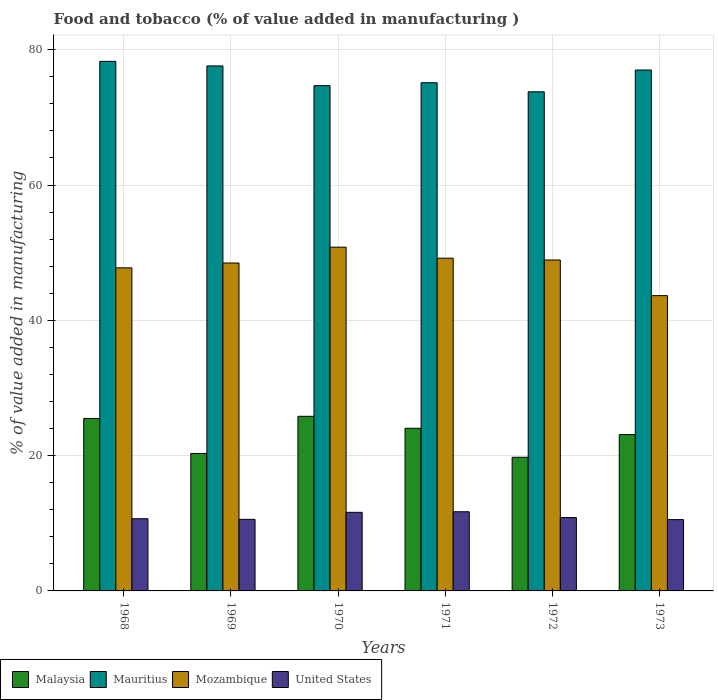Are the number of bars per tick equal to the number of legend labels?
Ensure brevity in your answer.  Yes. Are the number of bars on each tick of the X-axis equal?
Give a very brief answer. Yes. What is the value added in manufacturing food and tobacco in Malaysia in 1973?
Make the answer very short. 23.12. Across all years, what is the maximum value added in manufacturing food and tobacco in Mozambique?
Keep it short and to the point. 50.82. Across all years, what is the minimum value added in manufacturing food and tobacco in United States?
Your answer should be very brief. 10.54. What is the total value added in manufacturing food and tobacco in Mozambique in the graph?
Keep it short and to the point. 288.81. What is the difference between the value added in manufacturing food and tobacco in United States in 1969 and that in 1972?
Give a very brief answer. -0.27. What is the difference between the value added in manufacturing food and tobacco in Mauritius in 1968 and the value added in manufacturing food and tobacco in Malaysia in 1973?
Your answer should be compact. 55.17. What is the average value added in manufacturing food and tobacco in Mauritius per year?
Your answer should be very brief. 76.08. In the year 1972, what is the difference between the value added in manufacturing food and tobacco in United States and value added in manufacturing food and tobacco in Mauritius?
Offer a very short reply. -62.94. What is the ratio of the value added in manufacturing food and tobacco in United States in 1970 to that in 1973?
Provide a succinct answer. 1.1. What is the difference between the highest and the second highest value added in manufacturing food and tobacco in Malaysia?
Make the answer very short. 0.32. What is the difference between the highest and the lowest value added in manufacturing food and tobacco in United States?
Offer a terse response. 1.16. In how many years, is the value added in manufacturing food and tobacco in Malaysia greater than the average value added in manufacturing food and tobacco in Malaysia taken over all years?
Offer a very short reply. 4. Is the sum of the value added in manufacturing food and tobacco in United States in 1970 and 1971 greater than the maximum value added in manufacturing food and tobacco in Mauritius across all years?
Make the answer very short. No. What does the 1st bar from the left in 1971 represents?
Offer a terse response. Malaysia. What does the 4th bar from the right in 1970 represents?
Offer a terse response. Malaysia. Is it the case that in every year, the sum of the value added in manufacturing food and tobacco in Mozambique and value added in manufacturing food and tobacco in Malaysia is greater than the value added in manufacturing food and tobacco in Mauritius?
Ensure brevity in your answer.  No. How many bars are there?
Provide a succinct answer. 24. How many years are there in the graph?
Give a very brief answer. 6. Are the values on the major ticks of Y-axis written in scientific E-notation?
Ensure brevity in your answer.  No. Does the graph contain any zero values?
Give a very brief answer. No. Does the graph contain grids?
Give a very brief answer. Yes. Where does the legend appear in the graph?
Give a very brief answer. Bottom left. What is the title of the graph?
Keep it short and to the point. Food and tobacco (% of value added in manufacturing ). Does "South Sudan" appear as one of the legend labels in the graph?
Provide a succinct answer. No. What is the label or title of the X-axis?
Your answer should be very brief. Years. What is the label or title of the Y-axis?
Your answer should be compact. % of value added in manufacturing. What is the % of value added in manufacturing of Malaysia in 1968?
Offer a very short reply. 25.49. What is the % of value added in manufacturing in Mauritius in 1968?
Ensure brevity in your answer.  78.28. What is the % of value added in manufacturing in Mozambique in 1968?
Your response must be concise. 47.76. What is the % of value added in manufacturing of United States in 1968?
Give a very brief answer. 10.67. What is the % of value added in manufacturing of Malaysia in 1969?
Ensure brevity in your answer.  20.32. What is the % of value added in manufacturing in Mauritius in 1969?
Your response must be concise. 77.61. What is the % of value added in manufacturing of Mozambique in 1969?
Offer a terse response. 48.47. What is the % of value added in manufacturing in United States in 1969?
Give a very brief answer. 10.58. What is the % of value added in manufacturing of Malaysia in 1970?
Provide a succinct answer. 25.81. What is the % of value added in manufacturing of Mauritius in 1970?
Provide a succinct answer. 74.69. What is the % of value added in manufacturing of Mozambique in 1970?
Make the answer very short. 50.82. What is the % of value added in manufacturing of United States in 1970?
Keep it short and to the point. 11.62. What is the % of value added in manufacturing in Malaysia in 1971?
Ensure brevity in your answer.  24.04. What is the % of value added in manufacturing in Mauritius in 1971?
Provide a succinct answer. 75.13. What is the % of value added in manufacturing of Mozambique in 1971?
Your answer should be compact. 49.19. What is the % of value added in manufacturing in United States in 1971?
Keep it short and to the point. 11.71. What is the % of value added in manufacturing in Malaysia in 1972?
Your response must be concise. 19.76. What is the % of value added in manufacturing in Mauritius in 1972?
Make the answer very short. 73.79. What is the % of value added in manufacturing of Mozambique in 1972?
Provide a short and direct response. 48.92. What is the % of value added in manufacturing in United States in 1972?
Give a very brief answer. 10.85. What is the % of value added in manufacturing of Malaysia in 1973?
Make the answer very short. 23.12. What is the % of value added in manufacturing of Mauritius in 1973?
Offer a very short reply. 77. What is the % of value added in manufacturing of Mozambique in 1973?
Your answer should be very brief. 43.65. What is the % of value added in manufacturing in United States in 1973?
Your answer should be compact. 10.54. Across all years, what is the maximum % of value added in manufacturing in Malaysia?
Your answer should be compact. 25.81. Across all years, what is the maximum % of value added in manufacturing in Mauritius?
Your response must be concise. 78.28. Across all years, what is the maximum % of value added in manufacturing of Mozambique?
Offer a very short reply. 50.82. Across all years, what is the maximum % of value added in manufacturing of United States?
Provide a succinct answer. 11.71. Across all years, what is the minimum % of value added in manufacturing of Malaysia?
Your response must be concise. 19.76. Across all years, what is the minimum % of value added in manufacturing of Mauritius?
Make the answer very short. 73.79. Across all years, what is the minimum % of value added in manufacturing of Mozambique?
Give a very brief answer. 43.65. Across all years, what is the minimum % of value added in manufacturing in United States?
Your answer should be compact. 10.54. What is the total % of value added in manufacturing in Malaysia in the graph?
Ensure brevity in your answer.  138.54. What is the total % of value added in manufacturing of Mauritius in the graph?
Ensure brevity in your answer.  456.5. What is the total % of value added in manufacturing in Mozambique in the graph?
Make the answer very short. 288.81. What is the total % of value added in manufacturing in United States in the graph?
Offer a terse response. 65.97. What is the difference between the % of value added in manufacturing of Malaysia in 1968 and that in 1969?
Make the answer very short. 5.18. What is the difference between the % of value added in manufacturing in Mauritius in 1968 and that in 1969?
Your response must be concise. 0.68. What is the difference between the % of value added in manufacturing in Mozambique in 1968 and that in 1969?
Keep it short and to the point. -0.71. What is the difference between the % of value added in manufacturing of United States in 1968 and that in 1969?
Provide a short and direct response. 0.1. What is the difference between the % of value added in manufacturing of Malaysia in 1968 and that in 1970?
Your response must be concise. -0.32. What is the difference between the % of value added in manufacturing of Mauritius in 1968 and that in 1970?
Give a very brief answer. 3.59. What is the difference between the % of value added in manufacturing in Mozambique in 1968 and that in 1970?
Offer a terse response. -3.06. What is the difference between the % of value added in manufacturing of United States in 1968 and that in 1970?
Give a very brief answer. -0.94. What is the difference between the % of value added in manufacturing of Malaysia in 1968 and that in 1971?
Give a very brief answer. 1.45. What is the difference between the % of value added in manufacturing of Mauritius in 1968 and that in 1971?
Your answer should be very brief. 3.16. What is the difference between the % of value added in manufacturing in Mozambique in 1968 and that in 1971?
Provide a short and direct response. -1.43. What is the difference between the % of value added in manufacturing of United States in 1968 and that in 1971?
Your answer should be compact. -1.03. What is the difference between the % of value added in manufacturing in Malaysia in 1968 and that in 1972?
Offer a terse response. 5.74. What is the difference between the % of value added in manufacturing in Mauritius in 1968 and that in 1972?
Offer a terse response. 4.5. What is the difference between the % of value added in manufacturing of Mozambique in 1968 and that in 1972?
Provide a short and direct response. -1.16. What is the difference between the % of value added in manufacturing of United States in 1968 and that in 1972?
Ensure brevity in your answer.  -0.17. What is the difference between the % of value added in manufacturing of Malaysia in 1968 and that in 1973?
Offer a terse response. 2.38. What is the difference between the % of value added in manufacturing in Mauritius in 1968 and that in 1973?
Provide a short and direct response. 1.28. What is the difference between the % of value added in manufacturing in Mozambique in 1968 and that in 1973?
Offer a very short reply. 4.11. What is the difference between the % of value added in manufacturing in United States in 1968 and that in 1973?
Your answer should be compact. 0.13. What is the difference between the % of value added in manufacturing in Malaysia in 1969 and that in 1970?
Your answer should be compact. -5.49. What is the difference between the % of value added in manufacturing in Mauritius in 1969 and that in 1970?
Keep it short and to the point. 2.92. What is the difference between the % of value added in manufacturing in Mozambique in 1969 and that in 1970?
Your response must be concise. -2.34. What is the difference between the % of value added in manufacturing of United States in 1969 and that in 1970?
Ensure brevity in your answer.  -1.04. What is the difference between the % of value added in manufacturing of Malaysia in 1969 and that in 1971?
Provide a short and direct response. -3.72. What is the difference between the % of value added in manufacturing in Mauritius in 1969 and that in 1971?
Keep it short and to the point. 2.48. What is the difference between the % of value added in manufacturing in Mozambique in 1969 and that in 1971?
Offer a very short reply. -0.71. What is the difference between the % of value added in manufacturing in United States in 1969 and that in 1971?
Your answer should be compact. -1.13. What is the difference between the % of value added in manufacturing in Malaysia in 1969 and that in 1972?
Your answer should be very brief. 0.56. What is the difference between the % of value added in manufacturing in Mauritius in 1969 and that in 1972?
Your answer should be compact. 3.82. What is the difference between the % of value added in manufacturing in Mozambique in 1969 and that in 1972?
Provide a short and direct response. -0.45. What is the difference between the % of value added in manufacturing in United States in 1969 and that in 1972?
Offer a very short reply. -0.27. What is the difference between the % of value added in manufacturing in Malaysia in 1969 and that in 1973?
Provide a succinct answer. -2.8. What is the difference between the % of value added in manufacturing of Mauritius in 1969 and that in 1973?
Give a very brief answer. 0.61. What is the difference between the % of value added in manufacturing in Mozambique in 1969 and that in 1973?
Provide a succinct answer. 4.82. What is the difference between the % of value added in manufacturing of United States in 1969 and that in 1973?
Ensure brevity in your answer.  0.03. What is the difference between the % of value added in manufacturing of Malaysia in 1970 and that in 1971?
Give a very brief answer. 1.77. What is the difference between the % of value added in manufacturing of Mauritius in 1970 and that in 1971?
Your answer should be very brief. -0.43. What is the difference between the % of value added in manufacturing of Mozambique in 1970 and that in 1971?
Make the answer very short. 1.63. What is the difference between the % of value added in manufacturing in United States in 1970 and that in 1971?
Offer a terse response. -0.09. What is the difference between the % of value added in manufacturing in Malaysia in 1970 and that in 1972?
Your answer should be compact. 6.05. What is the difference between the % of value added in manufacturing in Mauritius in 1970 and that in 1972?
Ensure brevity in your answer.  0.91. What is the difference between the % of value added in manufacturing in Mozambique in 1970 and that in 1972?
Your answer should be compact. 1.9. What is the difference between the % of value added in manufacturing of United States in 1970 and that in 1972?
Give a very brief answer. 0.77. What is the difference between the % of value added in manufacturing in Malaysia in 1970 and that in 1973?
Provide a succinct answer. 2.7. What is the difference between the % of value added in manufacturing of Mauritius in 1970 and that in 1973?
Your answer should be compact. -2.31. What is the difference between the % of value added in manufacturing of Mozambique in 1970 and that in 1973?
Your answer should be very brief. 7.16. What is the difference between the % of value added in manufacturing of United States in 1970 and that in 1973?
Your response must be concise. 1.08. What is the difference between the % of value added in manufacturing of Malaysia in 1971 and that in 1972?
Keep it short and to the point. 4.28. What is the difference between the % of value added in manufacturing in Mauritius in 1971 and that in 1972?
Offer a terse response. 1.34. What is the difference between the % of value added in manufacturing of Mozambique in 1971 and that in 1972?
Provide a short and direct response. 0.27. What is the difference between the % of value added in manufacturing in United States in 1971 and that in 1972?
Keep it short and to the point. 0.86. What is the difference between the % of value added in manufacturing of Malaysia in 1971 and that in 1973?
Your answer should be very brief. 0.93. What is the difference between the % of value added in manufacturing of Mauritius in 1971 and that in 1973?
Provide a succinct answer. -1.87. What is the difference between the % of value added in manufacturing in Mozambique in 1971 and that in 1973?
Give a very brief answer. 5.54. What is the difference between the % of value added in manufacturing of United States in 1971 and that in 1973?
Your answer should be very brief. 1.16. What is the difference between the % of value added in manufacturing of Malaysia in 1972 and that in 1973?
Your response must be concise. -3.36. What is the difference between the % of value added in manufacturing of Mauritius in 1972 and that in 1973?
Keep it short and to the point. -3.22. What is the difference between the % of value added in manufacturing of Mozambique in 1972 and that in 1973?
Your answer should be very brief. 5.27. What is the difference between the % of value added in manufacturing in United States in 1972 and that in 1973?
Ensure brevity in your answer.  0.3. What is the difference between the % of value added in manufacturing of Malaysia in 1968 and the % of value added in manufacturing of Mauritius in 1969?
Your answer should be compact. -52.11. What is the difference between the % of value added in manufacturing in Malaysia in 1968 and the % of value added in manufacturing in Mozambique in 1969?
Ensure brevity in your answer.  -22.98. What is the difference between the % of value added in manufacturing of Malaysia in 1968 and the % of value added in manufacturing of United States in 1969?
Offer a very short reply. 14.92. What is the difference between the % of value added in manufacturing of Mauritius in 1968 and the % of value added in manufacturing of Mozambique in 1969?
Your answer should be compact. 29.81. What is the difference between the % of value added in manufacturing in Mauritius in 1968 and the % of value added in manufacturing in United States in 1969?
Offer a very short reply. 67.71. What is the difference between the % of value added in manufacturing in Mozambique in 1968 and the % of value added in manufacturing in United States in 1969?
Ensure brevity in your answer.  37.18. What is the difference between the % of value added in manufacturing of Malaysia in 1968 and the % of value added in manufacturing of Mauritius in 1970?
Provide a succinct answer. -49.2. What is the difference between the % of value added in manufacturing in Malaysia in 1968 and the % of value added in manufacturing in Mozambique in 1970?
Your answer should be very brief. -25.32. What is the difference between the % of value added in manufacturing of Malaysia in 1968 and the % of value added in manufacturing of United States in 1970?
Provide a short and direct response. 13.88. What is the difference between the % of value added in manufacturing in Mauritius in 1968 and the % of value added in manufacturing in Mozambique in 1970?
Give a very brief answer. 27.47. What is the difference between the % of value added in manufacturing in Mauritius in 1968 and the % of value added in manufacturing in United States in 1970?
Ensure brevity in your answer.  66.67. What is the difference between the % of value added in manufacturing in Mozambique in 1968 and the % of value added in manufacturing in United States in 1970?
Offer a very short reply. 36.14. What is the difference between the % of value added in manufacturing of Malaysia in 1968 and the % of value added in manufacturing of Mauritius in 1971?
Your answer should be compact. -49.63. What is the difference between the % of value added in manufacturing of Malaysia in 1968 and the % of value added in manufacturing of Mozambique in 1971?
Your answer should be very brief. -23.69. What is the difference between the % of value added in manufacturing in Malaysia in 1968 and the % of value added in manufacturing in United States in 1971?
Provide a short and direct response. 13.79. What is the difference between the % of value added in manufacturing in Mauritius in 1968 and the % of value added in manufacturing in Mozambique in 1971?
Keep it short and to the point. 29.1. What is the difference between the % of value added in manufacturing in Mauritius in 1968 and the % of value added in manufacturing in United States in 1971?
Make the answer very short. 66.58. What is the difference between the % of value added in manufacturing in Mozambique in 1968 and the % of value added in manufacturing in United States in 1971?
Offer a very short reply. 36.06. What is the difference between the % of value added in manufacturing in Malaysia in 1968 and the % of value added in manufacturing in Mauritius in 1972?
Provide a short and direct response. -48.29. What is the difference between the % of value added in manufacturing in Malaysia in 1968 and the % of value added in manufacturing in Mozambique in 1972?
Offer a terse response. -23.43. What is the difference between the % of value added in manufacturing in Malaysia in 1968 and the % of value added in manufacturing in United States in 1972?
Keep it short and to the point. 14.65. What is the difference between the % of value added in manufacturing in Mauritius in 1968 and the % of value added in manufacturing in Mozambique in 1972?
Give a very brief answer. 29.36. What is the difference between the % of value added in manufacturing in Mauritius in 1968 and the % of value added in manufacturing in United States in 1972?
Your answer should be compact. 67.44. What is the difference between the % of value added in manufacturing of Mozambique in 1968 and the % of value added in manufacturing of United States in 1972?
Provide a succinct answer. 36.92. What is the difference between the % of value added in manufacturing in Malaysia in 1968 and the % of value added in manufacturing in Mauritius in 1973?
Keep it short and to the point. -51.51. What is the difference between the % of value added in manufacturing of Malaysia in 1968 and the % of value added in manufacturing of Mozambique in 1973?
Keep it short and to the point. -18.16. What is the difference between the % of value added in manufacturing in Malaysia in 1968 and the % of value added in manufacturing in United States in 1973?
Your response must be concise. 14.95. What is the difference between the % of value added in manufacturing in Mauritius in 1968 and the % of value added in manufacturing in Mozambique in 1973?
Give a very brief answer. 34.63. What is the difference between the % of value added in manufacturing in Mauritius in 1968 and the % of value added in manufacturing in United States in 1973?
Ensure brevity in your answer.  67.74. What is the difference between the % of value added in manufacturing of Mozambique in 1968 and the % of value added in manufacturing of United States in 1973?
Provide a short and direct response. 37.22. What is the difference between the % of value added in manufacturing in Malaysia in 1969 and the % of value added in manufacturing in Mauritius in 1970?
Make the answer very short. -54.37. What is the difference between the % of value added in manufacturing of Malaysia in 1969 and the % of value added in manufacturing of Mozambique in 1970?
Ensure brevity in your answer.  -30.5. What is the difference between the % of value added in manufacturing in Malaysia in 1969 and the % of value added in manufacturing in United States in 1970?
Make the answer very short. 8.7. What is the difference between the % of value added in manufacturing in Mauritius in 1969 and the % of value added in manufacturing in Mozambique in 1970?
Give a very brief answer. 26.79. What is the difference between the % of value added in manufacturing in Mauritius in 1969 and the % of value added in manufacturing in United States in 1970?
Provide a short and direct response. 65.99. What is the difference between the % of value added in manufacturing in Mozambique in 1969 and the % of value added in manufacturing in United States in 1970?
Your answer should be compact. 36.86. What is the difference between the % of value added in manufacturing in Malaysia in 1969 and the % of value added in manufacturing in Mauritius in 1971?
Give a very brief answer. -54.81. What is the difference between the % of value added in manufacturing in Malaysia in 1969 and the % of value added in manufacturing in Mozambique in 1971?
Give a very brief answer. -28.87. What is the difference between the % of value added in manufacturing of Malaysia in 1969 and the % of value added in manufacturing of United States in 1971?
Your answer should be very brief. 8.61. What is the difference between the % of value added in manufacturing in Mauritius in 1969 and the % of value added in manufacturing in Mozambique in 1971?
Give a very brief answer. 28.42. What is the difference between the % of value added in manufacturing in Mauritius in 1969 and the % of value added in manufacturing in United States in 1971?
Provide a succinct answer. 65.9. What is the difference between the % of value added in manufacturing in Mozambique in 1969 and the % of value added in manufacturing in United States in 1971?
Your answer should be compact. 36.77. What is the difference between the % of value added in manufacturing in Malaysia in 1969 and the % of value added in manufacturing in Mauritius in 1972?
Give a very brief answer. -53.47. What is the difference between the % of value added in manufacturing of Malaysia in 1969 and the % of value added in manufacturing of Mozambique in 1972?
Your answer should be very brief. -28.6. What is the difference between the % of value added in manufacturing of Malaysia in 1969 and the % of value added in manufacturing of United States in 1972?
Give a very brief answer. 9.47. What is the difference between the % of value added in manufacturing in Mauritius in 1969 and the % of value added in manufacturing in Mozambique in 1972?
Give a very brief answer. 28.69. What is the difference between the % of value added in manufacturing in Mauritius in 1969 and the % of value added in manufacturing in United States in 1972?
Keep it short and to the point. 66.76. What is the difference between the % of value added in manufacturing in Mozambique in 1969 and the % of value added in manufacturing in United States in 1972?
Your answer should be very brief. 37.63. What is the difference between the % of value added in manufacturing in Malaysia in 1969 and the % of value added in manufacturing in Mauritius in 1973?
Provide a short and direct response. -56.68. What is the difference between the % of value added in manufacturing of Malaysia in 1969 and the % of value added in manufacturing of Mozambique in 1973?
Your answer should be compact. -23.33. What is the difference between the % of value added in manufacturing of Malaysia in 1969 and the % of value added in manufacturing of United States in 1973?
Ensure brevity in your answer.  9.78. What is the difference between the % of value added in manufacturing of Mauritius in 1969 and the % of value added in manufacturing of Mozambique in 1973?
Offer a very short reply. 33.96. What is the difference between the % of value added in manufacturing of Mauritius in 1969 and the % of value added in manufacturing of United States in 1973?
Your response must be concise. 67.07. What is the difference between the % of value added in manufacturing in Mozambique in 1969 and the % of value added in manufacturing in United States in 1973?
Offer a terse response. 37.93. What is the difference between the % of value added in manufacturing in Malaysia in 1970 and the % of value added in manufacturing in Mauritius in 1971?
Provide a short and direct response. -49.32. What is the difference between the % of value added in manufacturing of Malaysia in 1970 and the % of value added in manufacturing of Mozambique in 1971?
Provide a short and direct response. -23.37. What is the difference between the % of value added in manufacturing in Malaysia in 1970 and the % of value added in manufacturing in United States in 1971?
Your answer should be compact. 14.11. What is the difference between the % of value added in manufacturing of Mauritius in 1970 and the % of value added in manufacturing of Mozambique in 1971?
Offer a terse response. 25.51. What is the difference between the % of value added in manufacturing of Mauritius in 1970 and the % of value added in manufacturing of United States in 1971?
Offer a terse response. 62.99. What is the difference between the % of value added in manufacturing in Mozambique in 1970 and the % of value added in manufacturing in United States in 1971?
Your answer should be very brief. 39.11. What is the difference between the % of value added in manufacturing in Malaysia in 1970 and the % of value added in manufacturing in Mauritius in 1972?
Keep it short and to the point. -47.97. What is the difference between the % of value added in manufacturing of Malaysia in 1970 and the % of value added in manufacturing of Mozambique in 1972?
Offer a very short reply. -23.11. What is the difference between the % of value added in manufacturing of Malaysia in 1970 and the % of value added in manufacturing of United States in 1972?
Provide a succinct answer. 14.97. What is the difference between the % of value added in manufacturing in Mauritius in 1970 and the % of value added in manufacturing in Mozambique in 1972?
Give a very brief answer. 25.77. What is the difference between the % of value added in manufacturing in Mauritius in 1970 and the % of value added in manufacturing in United States in 1972?
Give a very brief answer. 63.85. What is the difference between the % of value added in manufacturing in Mozambique in 1970 and the % of value added in manufacturing in United States in 1972?
Your answer should be compact. 39.97. What is the difference between the % of value added in manufacturing in Malaysia in 1970 and the % of value added in manufacturing in Mauritius in 1973?
Your response must be concise. -51.19. What is the difference between the % of value added in manufacturing of Malaysia in 1970 and the % of value added in manufacturing of Mozambique in 1973?
Make the answer very short. -17.84. What is the difference between the % of value added in manufacturing in Malaysia in 1970 and the % of value added in manufacturing in United States in 1973?
Offer a terse response. 15.27. What is the difference between the % of value added in manufacturing in Mauritius in 1970 and the % of value added in manufacturing in Mozambique in 1973?
Keep it short and to the point. 31.04. What is the difference between the % of value added in manufacturing of Mauritius in 1970 and the % of value added in manufacturing of United States in 1973?
Provide a succinct answer. 64.15. What is the difference between the % of value added in manufacturing of Mozambique in 1970 and the % of value added in manufacturing of United States in 1973?
Your answer should be compact. 40.27. What is the difference between the % of value added in manufacturing in Malaysia in 1971 and the % of value added in manufacturing in Mauritius in 1972?
Offer a very short reply. -49.74. What is the difference between the % of value added in manufacturing of Malaysia in 1971 and the % of value added in manufacturing of Mozambique in 1972?
Keep it short and to the point. -24.88. What is the difference between the % of value added in manufacturing of Malaysia in 1971 and the % of value added in manufacturing of United States in 1972?
Your answer should be compact. 13.2. What is the difference between the % of value added in manufacturing of Mauritius in 1971 and the % of value added in manufacturing of Mozambique in 1972?
Give a very brief answer. 26.21. What is the difference between the % of value added in manufacturing in Mauritius in 1971 and the % of value added in manufacturing in United States in 1972?
Give a very brief answer. 64.28. What is the difference between the % of value added in manufacturing in Mozambique in 1971 and the % of value added in manufacturing in United States in 1972?
Provide a succinct answer. 38.34. What is the difference between the % of value added in manufacturing of Malaysia in 1971 and the % of value added in manufacturing of Mauritius in 1973?
Offer a very short reply. -52.96. What is the difference between the % of value added in manufacturing of Malaysia in 1971 and the % of value added in manufacturing of Mozambique in 1973?
Offer a terse response. -19.61. What is the difference between the % of value added in manufacturing in Malaysia in 1971 and the % of value added in manufacturing in United States in 1973?
Offer a very short reply. 13.5. What is the difference between the % of value added in manufacturing of Mauritius in 1971 and the % of value added in manufacturing of Mozambique in 1973?
Your response must be concise. 31.48. What is the difference between the % of value added in manufacturing of Mauritius in 1971 and the % of value added in manufacturing of United States in 1973?
Ensure brevity in your answer.  64.59. What is the difference between the % of value added in manufacturing in Mozambique in 1971 and the % of value added in manufacturing in United States in 1973?
Provide a short and direct response. 38.64. What is the difference between the % of value added in manufacturing of Malaysia in 1972 and the % of value added in manufacturing of Mauritius in 1973?
Offer a terse response. -57.24. What is the difference between the % of value added in manufacturing in Malaysia in 1972 and the % of value added in manufacturing in Mozambique in 1973?
Ensure brevity in your answer.  -23.89. What is the difference between the % of value added in manufacturing in Malaysia in 1972 and the % of value added in manufacturing in United States in 1973?
Provide a short and direct response. 9.21. What is the difference between the % of value added in manufacturing of Mauritius in 1972 and the % of value added in manufacturing of Mozambique in 1973?
Provide a succinct answer. 30.13. What is the difference between the % of value added in manufacturing in Mauritius in 1972 and the % of value added in manufacturing in United States in 1973?
Make the answer very short. 63.24. What is the difference between the % of value added in manufacturing of Mozambique in 1972 and the % of value added in manufacturing of United States in 1973?
Offer a very short reply. 38.38. What is the average % of value added in manufacturing in Malaysia per year?
Offer a terse response. 23.09. What is the average % of value added in manufacturing in Mauritius per year?
Provide a succinct answer. 76.08. What is the average % of value added in manufacturing of Mozambique per year?
Provide a short and direct response. 48.14. What is the average % of value added in manufacturing of United States per year?
Provide a short and direct response. 10.99. In the year 1968, what is the difference between the % of value added in manufacturing in Malaysia and % of value added in manufacturing in Mauritius?
Provide a short and direct response. -52.79. In the year 1968, what is the difference between the % of value added in manufacturing in Malaysia and % of value added in manufacturing in Mozambique?
Offer a very short reply. -22.27. In the year 1968, what is the difference between the % of value added in manufacturing in Malaysia and % of value added in manufacturing in United States?
Ensure brevity in your answer.  14.82. In the year 1968, what is the difference between the % of value added in manufacturing in Mauritius and % of value added in manufacturing in Mozambique?
Offer a very short reply. 30.52. In the year 1968, what is the difference between the % of value added in manufacturing of Mauritius and % of value added in manufacturing of United States?
Provide a succinct answer. 67.61. In the year 1968, what is the difference between the % of value added in manufacturing of Mozambique and % of value added in manufacturing of United States?
Your response must be concise. 37.09. In the year 1969, what is the difference between the % of value added in manufacturing of Malaysia and % of value added in manufacturing of Mauritius?
Make the answer very short. -57.29. In the year 1969, what is the difference between the % of value added in manufacturing of Malaysia and % of value added in manufacturing of Mozambique?
Your response must be concise. -28.15. In the year 1969, what is the difference between the % of value added in manufacturing of Malaysia and % of value added in manufacturing of United States?
Offer a terse response. 9.74. In the year 1969, what is the difference between the % of value added in manufacturing of Mauritius and % of value added in manufacturing of Mozambique?
Your response must be concise. 29.14. In the year 1969, what is the difference between the % of value added in manufacturing of Mauritius and % of value added in manufacturing of United States?
Your response must be concise. 67.03. In the year 1969, what is the difference between the % of value added in manufacturing of Mozambique and % of value added in manufacturing of United States?
Make the answer very short. 37.9. In the year 1970, what is the difference between the % of value added in manufacturing in Malaysia and % of value added in manufacturing in Mauritius?
Your answer should be very brief. -48.88. In the year 1970, what is the difference between the % of value added in manufacturing in Malaysia and % of value added in manufacturing in Mozambique?
Your response must be concise. -25. In the year 1970, what is the difference between the % of value added in manufacturing of Malaysia and % of value added in manufacturing of United States?
Your response must be concise. 14.19. In the year 1970, what is the difference between the % of value added in manufacturing in Mauritius and % of value added in manufacturing in Mozambique?
Ensure brevity in your answer.  23.88. In the year 1970, what is the difference between the % of value added in manufacturing of Mauritius and % of value added in manufacturing of United States?
Keep it short and to the point. 63.07. In the year 1970, what is the difference between the % of value added in manufacturing in Mozambique and % of value added in manufacturing in United States?
Provide a short and direct response. 39.2. In the year 1971, what is the difference between the % of value added in manufacturing of Malaysia and % of value added in manufacturing of Mauritius?
Give a very brief answer. -51.09. In the year 1971, what is the difference between the % of value added in manufacturing in Malaysia and % of value added in manufacturing in Mozambique?
Make the answer very short. -25.14. In the year 1971, what is the difference between the % of value added in manufacturing in Malaysia and % of value added in manufacturing in United States?
Offer a very short reply. 12.34. In the year 1971, what is the difference between the % of value added in manufacturing in Mauritius and % of value added in manufacturing in Mozambique?
Give a very brief answer. 25.94. In the year 1971, what is the difference between the % of value added in manufacturing in Mauritius and % of value added in manufacturing in United States?
Ensure brevity in your answer.  63.42. In the year 1971, what is the difference between the % of value added in manufacturing in Mozambique and % of value added in manufacturing in United States?
Ensure brevity in your answer.  37.48. In the year 1972, what is the difference between the % of value added in manufacturing in Malaysia and % of value added in manufacturing in Mauritius?
Make the answer very short. -54.03. In the year 1972, what is the difference between the % of value added in manufacturing of Malaysia and % of value added in manufacturing of Mozambique?
Make the answer very short. -29.16. In the year 1972, what is the difference between the % of value added in manufacturing of Malaysia and % of value added in manufacturing of United States?
Your answer should be very brief. 8.91. In the year 1972, what is the difference between the % of value added in manufacturing of Mauritius and % of value added in manufacturing of Mozambique?
Provide a short and direct response. 24.86. In the year 1972, what is the difference between the % of value added in manufacturing in Mauritius and % of value added in manufacturing in United States?
Keep it short and to the point. 62.94. In the year 1972, what is the difference between the % of value added in manufacturing of Mozambique and % of value added in manufacturing of United States?
Ensure brevity in your answer.  38.08. In the year 1973, what is the difference between the % of value added in manufacturing in Malaysia and % of value added in manufacturing in Mauritius?
Give a very brief answer. -53.89. In the year 1973, what is the difference between the % of value added in manufacturing in Malaysia and % of value added in manufacturing in Mozambique?
Your answer should be compact. -20.53. In the year 1973, what is the difference between the % of value added in manufacturing in Malaysia and % of value added in manufacturing in United States?
Provide a succinct answer. 12.57. In the year 1973, what is the difference between the % of value added in manufacturing in Mauritius and % of value added in manufacturing in Mozambique?
Ensure brevity in your answer.  33.35. In the year 1973, what is the difference between the % of value added in manufacturing of Mauritius and % of value added in manufacturing of United States?
Offer a very short reply. 66.46. In the year 1973, what is the difference between the % of value added in manufacturing of Mozambique and % of value added in manufacturing of United States?
Keep it short and to the point. 33.11. What is the ratio of the % of value added in manufacturing of Malaysia in 1968 to that in 1969?
Your response must be concise. 1.25. What is the ratio of the % of value added in manufacturing of Mauritius in 1968 to that in 1969?
Your response must be concise. 1.01. What is the ratio of the % of value added in manufacturing in Mozambique in 1968 to that in 1969?
Keep it short and to the point. 0.99. What is the ratio of the % of value added in manufacturing in United States in 1968 to that in 1969?
Your answer should be very brief. 1.01. What is the ratio of the % of value added in manufacturing of Mauritius in 1968 to that in 1970?
Offer a very short reply. 1.05. What is the ratio of the % of value added in manufacturing in Mozambique in 1968 to that in 1970?
Offer a very short reply. 0.94. What is the ratio of the % of value added in manufacturing in United States in 1968 to that in 1970?
Provide a succinct answer. 0.92. What is the ratio of the % of value added in manufacturing of Malaysia in 1968 to that in 1971?
Ensure brevity in your answer.  1.06. What is the ratio of the % of value added in manufacturing of Mauritius in 1968 to that in 1971?
Offer a terse response. 1.04. What is the ratio of the % of value added in manufacturing of United States in 1968 to that in 1971?
Give a very brief answer. 0.91. What is the ratio of the % of value added in manufacturing of Malaysia in 1968 to that in 1972?
Keep it short and to the point. 1.29. What is the ratio of the % of value added in manufacturing in Mauritius in 1968 to that in 1972?
Ensure brevity in your answer.  1.06. What is the ratio of the % of value added in manufacturing in Mozambique in 1968 to that in 1972?
Make the answer very short. 0.98. What is the ratio of the % of value added in manufacturing of United States in 1968 to that in 1972?
Offer a very short reply. 0.98. What is the ratio of the % of value added in manufacturing in Malaysia in 1968 to that in 1973?
Keep it short and to the point. 1.1. What is the ratio of the % of value added in manufacturing in Mauritius in 1968 to that in 1973?
Your answer should be compact. 1.02. What is the ratio of the % of value added in manufacturing in Mozambique in 1968 to that in 1973?
Your answer should be very brief. 1.09. What is the ratio of the % of value added in manufacturing in United States in 1968 to that in 1973?
Your answer should be compact. 1.01. What is the ratio of the % of value added in manufacturing of Malaysia in 1969 to that in 1970?
Ensure brevity in your answer.  0.79. What is the ratio of the % of value added in manufacturing of Mauritius in 1969 to that in 1970?
Provide a succinct answer. 1.04. What is the ratio of the % of value added in manufacturing in Mozambique in 1969 to that in 1970?
Provide a succinct answer. 0.95. What is the ratio of the % of value added in manufacturing in United States in 1969 to that in 1970?
Your response must be concise. 0.91. What is the ratio of the % of value added in manufacturing in Malaysia in 1969 to that in 1971?
Provide a succinct answer. 0.85. What is the ratio of the % of value added in manufacturing of Mauritius in 1969 to that in 1971?
Offer a terse response. 1.03. What is the ratio of the % of value added in manufacturing in Mozambique in 1969 to that in 1971?
Give a very brief answer. 0.99. What is the ratio of the % of value added in manufacturing of United States in 1969 to that in 1971?
Offer a very short reply. 0.9. What is the ratio of the % of value added in manufacturing of Malaysia in 1969 to that in 1972?
Your answer should be very brief. 1.03. What is the ratio of the % of value added in manufacturing in Mauritius in 1969 to that in 1972?
Offer a terse response. 1.05. What is the ratio of the % of value added in manufacturing of Mozambique in 1969 to that in 1972?
Give a very brief answer. 0.99. What is the ratio of the % of value added in manufacturing in United States in 1969 to that in 1972?
Your answer should be compact. 0.98. What is the ratio of the % of value added in manufacturing of Malaysia in 1969 to that in 1973?
Provide a short and direct response. 0.88. What is the ratio of the % of value added in manufacturing in Mauritius in 1969 to that in 1973?
Your response must be concise. 1.01. What is the ratio of the % of value added in manufacturing in Mozambique in 1969 to that in 1973?
Offer a very short reply. 1.11. What is the ratio of the % of value added in manufacturing in Malaysia in 1970 to that in 1971?
Your response must be concise. 1.07. What is the ratio of the % of value added in manufacturing of Mauritius in 1970 to that in 1971?
Provide a succinct answer. 0.99. What is the ratio of the % of value added in manufacturing in Mozambique in 1970 to that in 1971?
Your answer should be compact. 1.03. What is the ratio of the % of value added in manufacturing in Malaysia in 1970 to that in 1972?
Ensure brevity in your answer.  1.31. What is the ratio of the % of value added in manufacturing of Mauritius in 1970 to that in 1972?
Ensure brevity in your answer.  1.01. What is the ratio of the % of value added in manufacturing of Mozambique in 1970 to that in 1972?
Offer a terse response. 1.04. What is the ratio of the % of value added in manufacturing of United States in 1970 to that in 1972?
Your answer should be compact. 1.07. What is the ratio of the % of value added in manufacturing in Malaysia in 1970 to that in 1973?
Ensure brevity in your answer.  1.12. What is the ratio of the % of value added in manufacturing in Mauritius in 1970 to that in 1973?
Offer a very short reply. 0.97. What is the ratio of the % of value added in manufacturing of Mozambique in 1970 to that in 1973?
Give a very brief answer. 1.16. What is the ratio of the % of value added in manufacturing in United States in 1970 to that in 1973?
Keep it short and to the point. 1.1. What is the ratio of the % of value added in manufacturing of Malaysia in 1971 to that in 1972?
Offer a very short reply. 1.22. What is the ratio of the % of value added in manufacturing in Mauritius in 1971 to that in 1972?
Your answer should be compact. 1.02. What is the ratio of the % of value added in manufacturing in Mozambique in 1971 to that in 1972?
Your answer should be very brief. 1.01. What is the ratio of the % of value added in manufacturing of United States in 1971 to that in 1972?
Offer a terse response. 1.08. What is the ratio of the % of value added in manufacturing in Mauritius in 1971 to that in 1973?
Make the answer very short. 0.98. What is the ratio of the % of value added in manufacturing in Mozambique in 1971 to that in 1973?
Your response must be concise. 1.13. What is the ratio of the % of value added in manufacturing in United States in 1971 to that in 1973?
Provide a succinct answer. 1.11. What is the ratio of the % of value added in manufacturing of Malaysia in 1972 to that in 1973?
Ensure brevity in your answer.  0.85. What is the ratio of the % of value added in manufacturing of Mauritius in 1972 to that in 1973?
Offer a terse response. 0.96. What is the ratio of the % of value added in manufacturing of Mozambique in 1972 to that in 1973?
Make the answer very short. 1.12. What is the ratio of the % of value added in manufacturing in United States in 1972 to that in 1973?
Ensure brevity in your answer.  1.03. What is the difference between the highest and the second highest % of value added in manufacturing in Malaysia?
Give a very brief answer. 0.32. What is the difference between the highest and the second highest % of value added in manufacturing of Mauritius?
Your answer should be very brief. 0.68. What is the difference between the highest and the second highest % of value added in manufacturing in Mozambique?
Your answer should be compact. 1.63. What is the difference between the highest and the second highest % of value added in manufacturing of United States?
Make the answer very short. 0.09. What is the difference between the highest and the lowest % of value added in manufacturing in Malaysia?
Your response must be concise. 6.05. What is the difference between the highest and the lowest % of value added in manufacturing of Mauritius?
Provide a short and direct response. 4.5. What is the difference between the highest and the lowest % of value added in manufacturing of Mozambique?
Your answer should be compact. 7.16. What is the difference between the highest and the lowest % of value added in manufacturing in United States?
Offer a terse response. 1.16. 